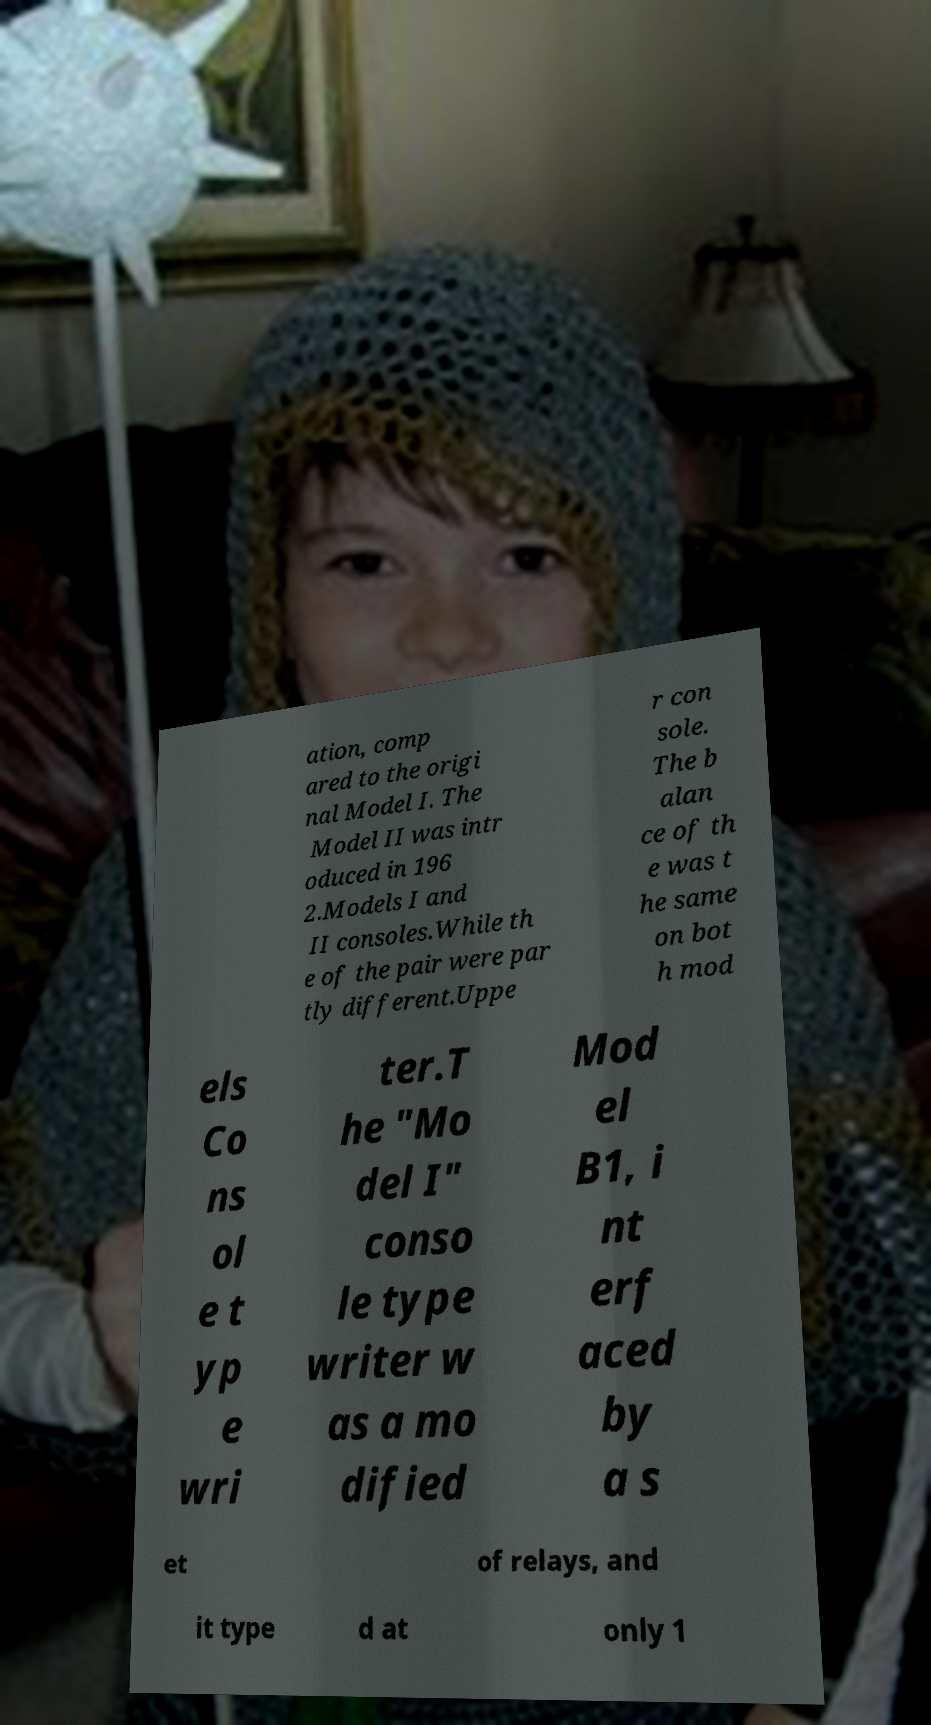There's text embedded in this image that I need extracted. Can you transcribe it verbatim? ation, comp ared to the origi nal Model I. The Model II was intr oduced in 196 2.Models I and II consoles.While th e of the pair were par tly different.Uppe r con sole. The b alan ce of th e was t he same on bot h mod els Co ns ol e t yp e wri ter.T he "Mo del I" conso le type writer w as a mo dified Mod el B1, i nt erf aced by a s et of relays, and it type d at only 1 